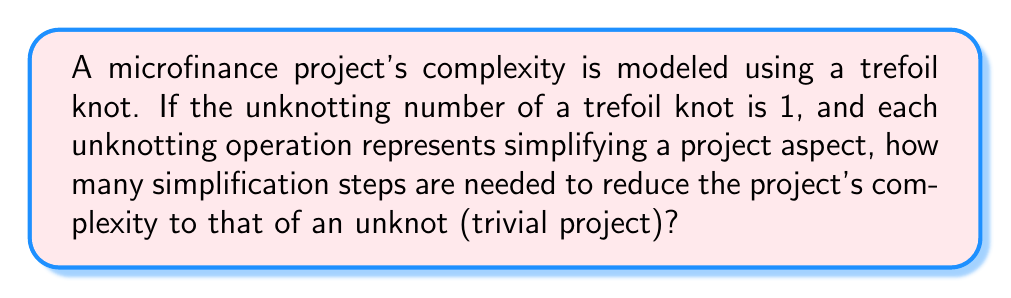Give your solution to this math problem. To solve this problem, we need to understand the concept of unknotting number and its relation to the trefoil knot:

1. The unknotting number of a knot is the minimum number of crossing changes required to transform the knot into an unknot (trivial knot).

2. For a trefoil knot, the unknotting number is 1. This means that a single crossing change is sufficient to transform it into an unknot.

3. In the context of the microfinance project:
   - The trefoil knot represents the initial complexity of the project.
   - The unknot represents a simplified, trivial project.
   - Each unknotting operation corresponds to a simplification step in the project.

4. Since the unknotting number of a trefoil knot is 1, we only need one simplification step to reduce the project's complexity to that of an unknot.

Mathematically, we can represent this as:

$$U(K_{\text{trefoil}}) = 1$$

Where $U(K)$ denotes the unknotting number of knot $K$.

This single unknotting operation transforms the trefoil knot into an unknot:

$$K_{\text{trefoil}} \xrightarrow{\text{1 operation}} K_{\text{unknot}}$$

Therefore, the number of simplification steps needed is equal to the unknotting number of the trefoil knot, which is 1.
Answer: 1 step 